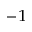<formula> <loc_0><loc_0><loc_500><loc_500>^ { - 1 }</formula> 